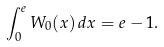<formula> <loc_0><loc_0><loc_500><loc_500>\int _ { 0 } ^ { e } W _ { 0 } ( x ) \, d x = e - 1 .</formula> 